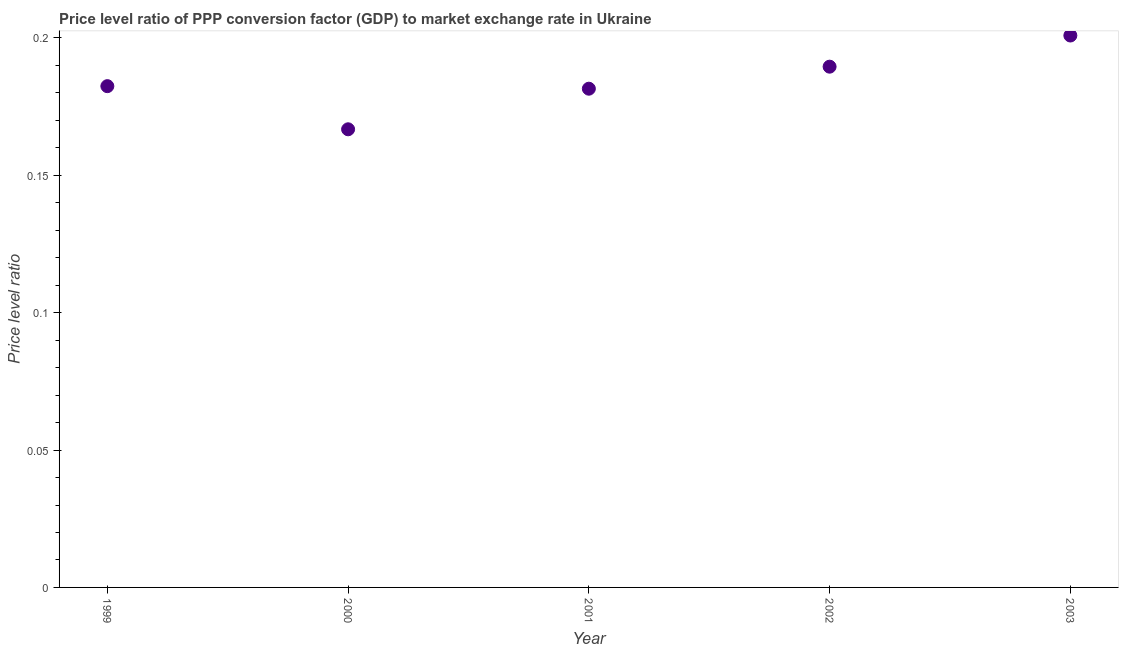What is the price level ratio in 1999?
Your response must be concise. 0.18. Across all years, what is the maximum price level ratio?
Offer a very short reply. 0.2. Across all years, what is the minimum price level ratio?
Make the answer very short. 0.17. In which year was the price level ratio minimum?
Your answer should be compact. 2000. What is the sum of the price level ratio?
Make the answer very short. 0.92. What is the difference between the price level ratio in 2000 and 2001?
Make the answer very short. -0.01. What is the average price level ratio per year?
Provide a succinct answer. 0.18. What is the median price level ratio?
Give a very brief answer. 0.18. In how many years, is the price level ratio greater than 0.03 ?
Make the answer very short. 5. What is the ratio of the price level ratio in 2002 to that in 2003?
Offer a very short reply. 0.94. Is the difference between the price level ratio in 1999 and 2001 greater than the difference between any two years?
Make the answer very short. No. What is the difference between the highest and the second highest price level ratio?
Offer a terse response. 0.01. What is the difference between the highest and the lowest price level ratio?
Offer a very short reply. 0.03. What is the difference between two consecutive major ticks on the Y-axis?
Make the answer very short. 0.05. Does the graph contain grids?
Provide a succinct answer. No. What is the title of the graph?
Provide a succinct answer. Price level ratio of PPP conversion factor (GDP) to market exchange rate in Ukraine. What is the label or title of the Y-axis?
Provide a succinct answer. Price level ratio. What is the Price level ratio in 1999?
Provide a succinct answer. 0.18. What is the Price level ratio in 2000?
Provide a short and direct response. 0.17. What is the Price level ratio in 2001?
Keep it short and to the point. 0.18. What is the Price level ratio in 2002?
Give a very brief answer. 0.19. What is the Price level ratio in 2003?
Offer a terse response. 0.2. What is the difference between the Price level ratio in 1999 and 2000?
Make the answer very short. 0.02. What is the difference between the Price level ratio in 1999 and 2001?
Your answer should be compact. 0. What is the difference between the Price level ratio in 1999 and 2002?
Keep it short and to the point. -0.01. What is the difference between the Price level ratio in 1999 and 2003?
Offer a very short reply. -0.02. What is the difference between the Price level ratio in 2000 and 2001?
Keep it short and to the point. -0.01. What is the difference between the Price level ratio in 2000 and 2002?
Give a very brief answer. -0.02. What is the difference between the Price level ratio in 2000 and 2003?
Provide a succinct answer. -0.03. What is the difference between the Price level ratio in 2001 and 2002?
Ensure brevity in your answer.  -0.01. What is the difference between the Price level ratio in 2001 and 2003?
Provide a short and direct response. -0.02. What is the difference between the Price level ratio in 2002 and 2003?
Provide a succinct answer. -0.01. What is the ratio of the Price level ratio in 1999 to that in 2000?
Make the answer very short. 1.09. What is the ratio of the Price level ratio in 1999 to that in 2001?
Provide a succinct answer. 1. What is the ratio of the Price level ratio in 1999 to that in 2003?
Give a very brief answer. 0.91. What is the ratio of the Price level ratio in 2000 to that in 2001?
Make the answer very short. 0.92. What is the ratio of the Price level ratio in 2000 to that in 2002?
Offer a terse response. 0.88. What is the ratio of the Price level ratio in 2000 to that in 2003?
Keep it short and to the point. 0.83. What is the ratio of the Price level ratio in 2001 to that in 2002?
Provide a succinct answer. 0.96. What is the ratio of the Price level ratio in 2001 to that in 2003?
Keep it short and to the point. 0.9. What is the ratio of the Price level ratio in 2002 to that in 2003?
Provide a succinct answer. 0.94. 